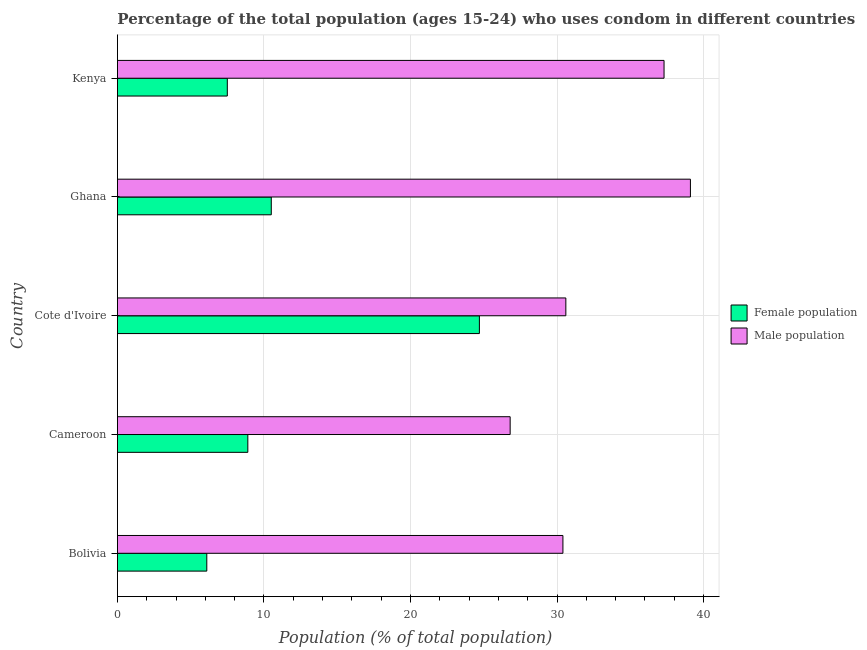Are the number of bars on each tick of the Y-axis equal?
Make the answer very short. Yes. How many bars are there on the 4th tick from the top?
Offer a terse response. 2. What is the label of the 2nd group of bars from the top?
Your response must be concise. Ghana. Across all countries, what is the maximum female population?
Your answer should be compact. 24.7. Across all countries, what is the minimum male population?
Provide a succinct answer. 26.8. In which country was the female population maximum?
Your answer should be compact. Cote d'Ivoire. In which country was the female population minimum?
Provide a succinct answer. Bolivia. What is the total male population in the graph?
Provide a short and direct response. 164.2. What is the difference between the female population in Cote d'Ivoire and that in Ghana?
Your answer should be very brief. 14.2. What is the difference between the male population in Cote d'Ivoire and the female population in Bolivia?
Your answer should be compact. 24.5. What is the average female population per country?
Your response must be concise. 11.54. In how many countries, is the male population greater than 30 %?
Your response must be concise. 4. Is the male population in Cameroon less than that in Ghana?
Give a very brief answer. Yes. What is the difference between the highest and the second highest female population?
Offer a terse response. 14.2. In how many countries, is the female population greater than the average female population taken over all countries?
Your answer should be compact. 1. Is the sum of the male population in Bolivia and Cameroon greater than the maximum female population across all countries?
Make the answer very short. Yes. What does the 2nd bar from the top in Cameroon represents?
Make the answer very short. Female population. What does the 1st bar from the bottom in Bolivia represents?
Your answer should be compact. Female population. Does the graph contain any zero values?
Give a very brief answer. No. Does the graph contain grids?
Your response must be concise. Yes. Where does the legend appear in the graph?
Give a very brief answer. Center right. How many legend labels are there?
Your answer should be very brief. 2. How are the legend labels stacked?
Your answer should be very brief. Vertical. What is the title of the graph?
Provide a short and direct response. Percentage of the total population (ages 15-24) who uses condom in different countries. Does "Female population" appear as one of the legend labels in the graph?
Your answer should be very brief. Yes. What is the label or title of the X-axis?
Your answer should be compact. Population (% of total population) . What is the Population (% of total population)  in Male population in Bolivia?
Ensure brevity in your answer.  30.4. What is the Population (% of total population)  of Male population in Cameroon?
Your answer should be very brief. 26.8. What is the Population (% of total population)  in Female population in Cote d'Ivoire?
Offer a very short reply. 24.7. What is the Population (% of total population)  of Male population in Cote d'Ivoire?
Provide a short and direct response. 30.6. What is the Population (% of total population)  in Female population in Ghana?
Offer a terse response. 10.5. What is the Population (% of total population)  of Male population in Ghana?
Your response must be concise. 39.1. What is the Population (% of total population)  in Female population in Kenya?
Offer a very short reply. 7.5. What is the Population (% of total population)  of Male population in Kenya?
Offer a terse response. 37.3. Across all countries, what is the maximum Population (% of total population)  in Female population?
Your answer should be very brief. 24.7. Across all countries, what is the maximum Population (% of total population)  of Male population?
Provide a short and direct response. 39.1. Across all countries, what is the minimum Population (% of total population)  in Female population?
Give a very brief answer. 6.1. Across all countries, what is the minimum Population (% of total population)  of Male population?
Your answer should be very brief. 26.8. What is the total Population (% of total population)  of Female population in the graph?
Make the answer very short. 57.7. What is the total Population (% of total population)  in Male population in the graph?
Keep it short and to the point. 164.2. What is the difference between the Population (% of total population)  of Female population in Bolivia and that in Cameroon?
Give a very brief answer. -2.8. What is the difference between the Population (% of total population)  in Female population in Bolivia and that in Cote d'Ivoire?
Your answer should be very brief. -18.6. What is the difference between the Population (% of total population)  of Male population in Bolivia and that in Kenya?
Give a very brief answer. -6.9. What is the difference between the Population (% of total population)  in Female population in Cameroon and that in Cote d'Ivoire?
Give a very brief answer. -15.8. What is the difference between the Population (% of total population)  in Male population in Cameroon and that in Cote d'Ivoire?
Give a very brief answer. -3.8. What is the difference between the Population (% of total population)  of Female population in Cameroon and that in Ghana?
Offer a very short reply. -1.6. What is the difference between the Population (% of total population)  in Male population in Cameroon and that in Ghana?
Your response must be concise. -12.3. What is the difference between the Population (% of total population)  in Male population in Cameroon and that in Kenya?
Provide a short and direct response. -10.5. What is the difference between the Population (% of total population)  of Female population in Cote d'Ivoire and that in Ghana?
Your response must be concise. 14.2. What is the difference between the Population (% of total population)  in Male population in Cote d'Ivoire and that in Ghana?
Give a very brief answer. -8.5. What is the difference between the Population (% of total population)  in Female population in Cote d'Ivoire and that in Kenya?
Ensure brevity in your answer.  17.2. What is the difference between the Population (% of total population)  in Male population in Cote d'Ivoire and that in Kenya?
Offer a terse response. -6.7. What is the difference between the Population (% of total population)  in Female population in Bolivia and the Population (% of total population)  in Male population in Cameroon?
Offer a terse response. -20.7. What is the difference between the Population (% of total population)  in Female population in Bolivia and the Population (% of total population)  in Male population in Cote d'Ivoire?
Provide a short and direct response. -24.5. What is the difference between the Population (% of total population)  in Female population in Bolivia and the Population (% of total population)  in Male population in Ghana?
Your response must be concise. -33. What is the difference between the Population (% of total population)  of Female population in Bolivia and the Population (% of total population)  of Male population in Kenya?
Keep it short and to the point. -31.2. What is the difference between the Population (% of total population)  in Female population in Cameroon and the Population (% of total population)  in Male population in Cote d'Ivoire?
Provide a short and direct response. -21.7. What is the difference between the Population (% of total population)  in Female population in Cameroon and the Population (% of total population)  in Male population in Ghana?
Provide a short and direct response. -30.2. What is the difference between the Population (% of total population)  in Female population in Cameroon and the Population (% of total population)  in Male population in Kenya?
Keep it short and to the point. -28.4. What is the difference between the Population (% of total population)  of Female population in Cote d'Ivoire and the Population (% of total population)  of Male population in Ghana?
Provide a short and direct response. -14.4. What is the difference between the Population (% of total population)  of Female population in Ghana and the Population (% of total population)  of Male population in Kenya?
Offer a terse response. -26.8. What is the average Population (% of total population)  of Female population per country?
Your answer should be very brief. 11.54. What is the average Population (% of total population)  of Male population per country?
Keep it short and to the point. 32.84. What is the difference between the Population (% of total population)  in Female population and Population (% of total population)  in Male population in Bolivia?
Your answer should be compact. -24.3. What is the difference between the Population (% of total population)  of Female population and Population (% of total population)  of Male population in Cameroon?
Your answer should be very brief. -17.9. What is the difference between the Population (% of total population)  of Female population and Population (% of total population)  of Male population in Ghana?
Give a very brief answer. -28.6. What is the difference between the Population (% of total population)  of Female population and Population (% of total population)  of Male population in Kenya?
Your answer should be compact. -29.8. What is the ratio of the Population (% of total population)  in Female population in Bolivia to that in Cameroon?
Provide a succinct answer. 0.69. What is the ratio of the Population (% of total population)  in Male population in Bolivia to that in Cameroon?
Provide a succinct answer. 1.13. What is the ratio of the Population (% of total population)  of Female population in Bolivia to that in Cote d'Ivoire?
Offer a very short reply. 0.25. What is the ratio of the Population (% of total population)  in Male population in Bolivia to that in Cote d'Ivoire?
Provide a succinct answer. 0.99. What is the ratio of the Population (% of total population)  in Female population in Bolivia to that in Ghana?
Your answer should be very brief. 0.58. What is the ratio of the Population (% of total population)  in Male population in Bolivia to that in Ghana?
Your response must be concise. 0.78. What is the ratio of the Population (% of total population)  in Female population in Bolivia to that in Kenya?
Provide a short and direct response. 0.81. What is the ratio of the Population (% of total population)  in Male population in Bolivia to that in Kenya?
Offer a very short reply. 0.81. What is the ratio of the Population (% of total population)  of Female population in Cameroon to that in Cote d'Ivoire?
Offer a very short reply. 0.36. What is the ratio of the Population (% of total population)  in Male population in Cameroon to that in Cote d'Ivoire?
Provide a succinct answer. 0.88. What is the ratio of the Population (% of total population)  of Female population in Cameroon to that in Ghana?
Provide a short and direct response. 0.85. What is the ratio of the Population (% of total population)  of Male population in Cameroon to that in Ghana?
Ensure brevity in your answer.  0.69. What is the ratio of the Population (% of total population)  of Female population in Cameroon to that in Kenya?
Make the answer very short. 1.19. What is the ratio of the Population (% of total population)  of Male population in Cameroon to that in Kenya?
Keep it short and to the point. 0.72. What is the ratio of the Population (% of total population)  in Female population in Cote d'Ivoire to that in Ghana?
Offer a terse response. 2.35. What is the ratio of the Population (% of total population)  in Male population in Cote d'Ivoire to that in Ghana?
Offer a terse response. 0.78. What is the ratio of the Population (% of total population)  in Female population in Cote d'Ivoire to that in Kenya?
Offer a terse response. 3.29. What is the ratio of the Population (% of total population)  in Male population in Cote d'Ivoire to that in Kenya?
Offer a terse response. 0.82. What is the ratio of the Population (% of total population)  of Female population in Ghana to that in Kenya?
Provide a succinct answer. 1.4. What is the ratio of the Population (% of total population)  of Male population in Ghana to that in Kenya?
Provide a short and direct response. 1.05. What is the difference between the highest and the second highest Population (% of total population)  in Female population?
Keep it short and to the point. 14.2. What is the difference between the highest and the second highest Population (% of total population)  of Male population?
Make the answer very short. 1.8. What is the difference between the highest and the lowest Population (% of total population)  of Female population?
Provide a succinct answer. 18.6. What is the difference between the highest and the lowest Population (% of total population)  of Male population?
Provide a succinct answer. 12.3. 